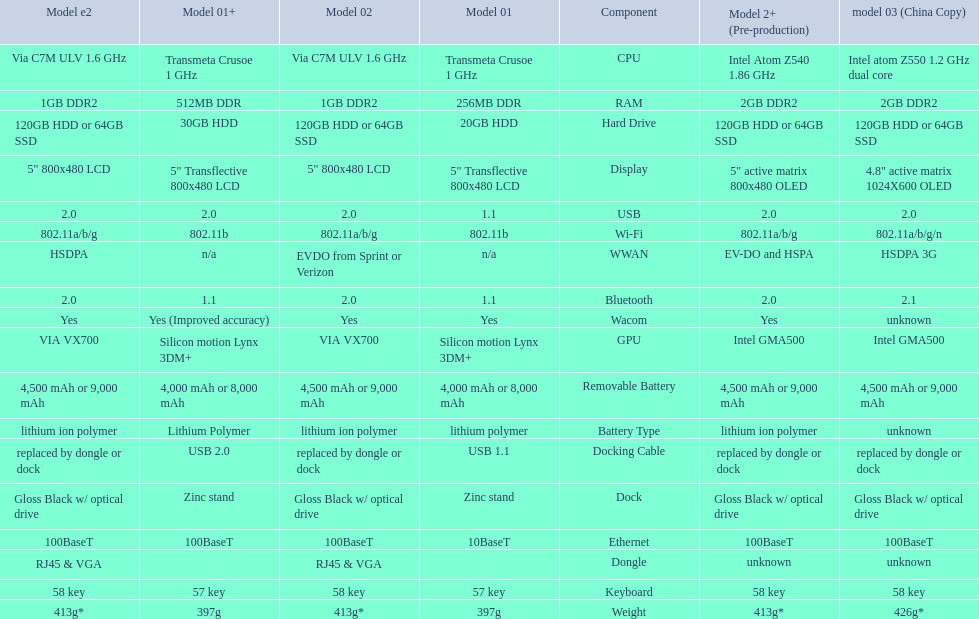How much more weight does the model 3 have over model 1? 29g. 